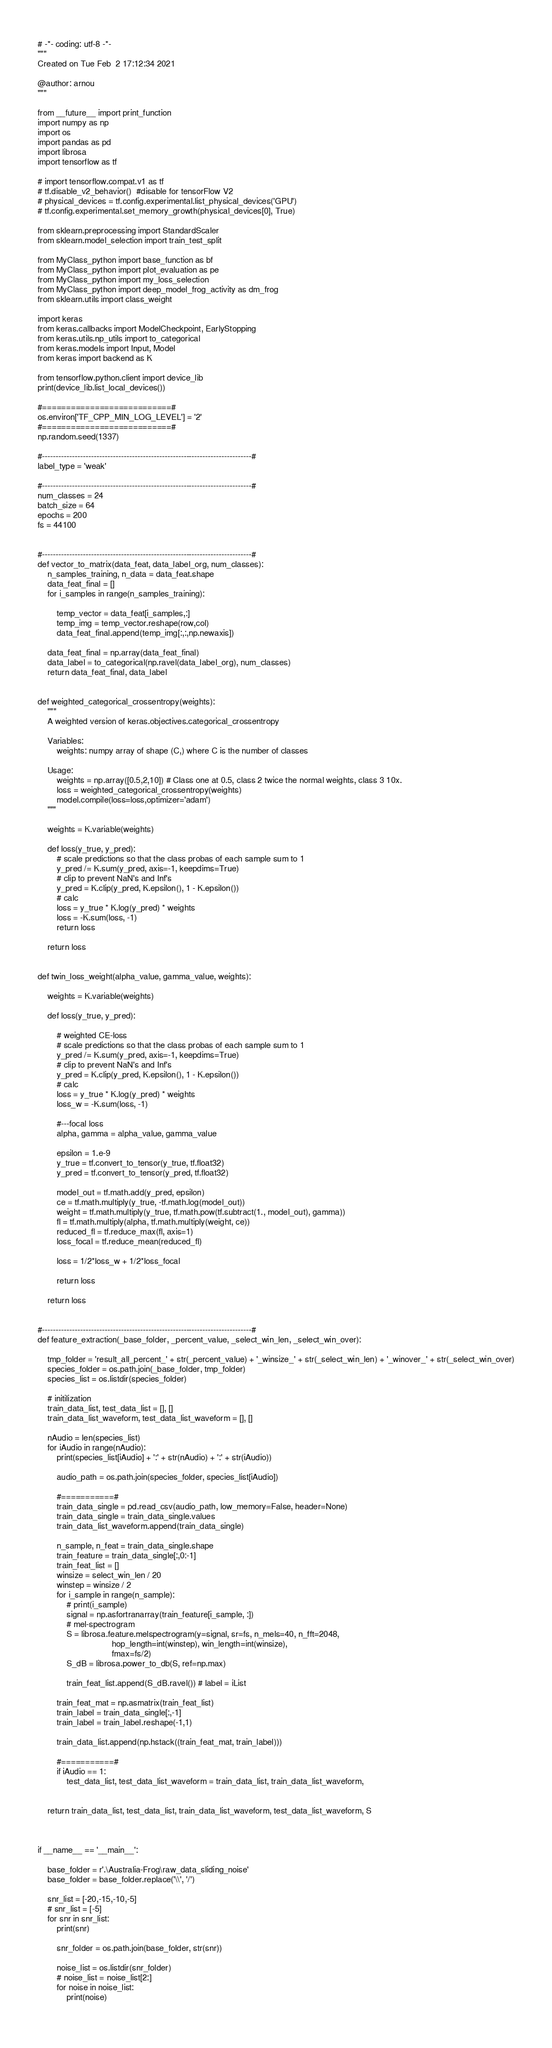Convert code to text. <code><loc_0><loc_0><loc_500><loc_500><_Python_># -*- coding: utf-8 -*-
"""
Created on Tue Feb  2 17:12:34 2021

@author: arnou
"""

from __future__ import print_function
import numpy as np
import os
import pandas as pd
import librosa
import tensorflow as tf

# import tensorflow.compat.v1 as tf
# tf.disable_v2_behavior()  #disable for tensorFlow V2
# physical_devices = tf.config.experimental.list_physical_devices('GPU')
# tf.config.experimental.set_memory_growth(physical_devices[0], True)

from sklearn.preprocessing import StandardScaler
from sklearn.model_selection import train_test_split

from MyClass_python import base_function as bf
from MyClass_python import plot_evaluation as pe
from MyClass_python import my_loss_selection
from MyClass_python import deep_model_frog_activity as dm_frog
from sklearn.utils import class_weight

import keras
from keras.callbacks import ModelCheckpoint, EarlyStopping
from keras.utils.np_utils import to_categorical
from keras.models import Input, Model
from keras import backend as K

from tensorflow.python.client import device_lib
print(device_lib.list_local_devices())

#===========================#
os.environ['TF_CPP_MIN_LOG_LEVEL'] = '2'
#===========================#
np.random.seed(1337)
    
#-----------------------------------------------------------------------------#
label_type = 'weak'

#-----------------------------------------------------------------------------#    
num_classes = 24
batch_size = 64
epochs = 200
fs = 44100


#-----------------------------------------------------------------------------#
def vector_to_matrix(data_feat, data_label_org, num_classes):
    n_samples_training, n_data = data_feat.shape 
    data_feat_final = []
    for i_samples in range(n_samples_training):
        
        temp_vector = data_feat[i_samples,:]    
        temp_img = temp_vector.reshape(row,col)    
        data_feat_final.append(temp_img[:,:,np.newaxis])

    data_feat_final = np.array(data_feat_final) 
    data_label = to_categorical(np.ravel(data_label_org), num_classes)    
    return data_feat_final, data_label


def weighted_categorical_crossentropy(weights):
    """
    A weighted version of keras.objectives.categorical_crossentropy

    Variables:
        weights: numpy array of shape (C,) where C is the number of classes

    Usage:
        weights = np.array([0.5,2,10]) # Class one at 0.5, class 2 twice the normal weights, class 3 10x.
        loss = weighted_categorical_crossentropy(weights)
        model.compile(loss=loss,optimizer='adam')
    """

    weights = K.variable(weights)

    def loss(y_true, y_pred):
        # scale predictions so that the class probas of each sample sum to 1
        y_pred /= K.sum(y_pred, axis=-1, keepdims=True)
        # clip to prevent NaN's and Inf's
        y_pred = K.clip(y_pred, K.epsilon(), 1 - K.epsilon())
        # calc
        loss = y_true * K.log(y_pred) * weights
        loss = -K.sum(loss, -1)
        return loss

    return loss


def twin_loss_weight(alpha_value, gamma_value, weights):
    
    weights = K.variable(weights)

    def loss(y_true, y_pred):
        
        # weighted CE-loss
        # scale predictions so that the class probas of each sample sum to 1
        y_pred /= K.sum(y_pred, axis=-1, keepdims=True)
        # clip to prevent NaN's and Inf's
        y_pred = K.clip(y_pred, K.epsilon(), 1 - K.epsilon())
        # calc
        loss = y_true * K.log(y_pred) * weights
        loss_w = -K.sum(loss, -1)
                
        #---focal loss
        alpha, gamma = alpha_value, gamma_value

        epsilon = 1.e-9
        y_true = tf.convert_to_tensor(y_true, tf.float32)
        y_pred = tf.convert_to_tensor(y_pred, tf.float32)
    
        model_out = tf.math.add(y_pred, epsilon)
        ce = tf.math.multiply(y_true, -tf.math.log(model_out))
        weight = tf.math.multiply(y_true, tf.math.pow(tf.subtract(1., model_out), gamma))
        fl = tf.math.multiply(alpha, tf.math.multiply(weight, ce))
        reduced_fl = tf.reduce_max(fl, axis=1)
        loss_focal = tf.reduce_mean(reduced_fl)
        
        loss = 1/2*loss_w + 1/2*loss_focal
                
        return loss

    return loss


#-----------------------------------------------------------------------------#
def feature_extraction(_base_folder, _percent_value, _select_win_len, _select_win_over):
    
    tmp_folder = 'result_all_percent_' + str(_percent_value) + '_winsize_' + str(_select_win_len) + '_winover_' + str(_select_win_over)
    species_folder = os.path.join(_base_folder, tmp_folder)    
    species_list = os.listdir(species_folder)
    
    # initilization
    train_data_list, test_data_list = [], []    
    train_data_list_waveform, test_data_list_waveform = [], []
    
    nAudio = len(species_list)
    for iAudio in range(nAudio):    
        print(species_list[iAudio] + ':' + str(nAudio) + ':' + str(iAudio))
        
        audio_path = os.path.join(species_folder, species_list[iAudio])
        
        #===========#                              
        train_data_single = pd.read_csv(audio_path, low_memory=False, header=None)                
        train_data_single = train_data_single.values
        train_data_list_waveform.append(train_data_single)
                       
        n_sample, n_feat = train_data_single.shape    
        train_feature = train_data_single[:,0:-1]
        train_feat_list = []                
        winsize = select_win_len / 20 
        winstep = winsize / 2                                     
        for i_sample in range(n_sample):
            # print(i_sample)
            signal = np.asfortranarray(train_feature[i_sample, :])
            # mel-spectrogram                         
            S = librosa.feature.melspectrogram(y=signal, sr=fs, n_mels=40, n_fft=2048, 
                               hop_length=int(winstep), win_length=int(winsize),
                               fmax=fs/2)                   
            S_dB = librosa.power_to_db(S, ref=np.max)
            
            train_feat_list.append(S_dB.ravel()) # label = iList
                
        train_feat_mat = np.asmatrix(train_feat_list)   
        train_label = train_data_single[:,-1]
        train_label = train_label.reshape(-1,1)
                 
        train_data_list.append(np.hstack((train_feat_mat, train_label)))
        
        #===========#
        if iAudio == 1:
            test_data_list, test_data_list_waveform = train_data_list, train_data_list_waveform, 
   
                    
    return train_data_list, test_data_list, train_data_list_waveform, test_data_list_waveform, S



if __name__ == '__main__':
    
    base_folder = r'.\Australia-Frog\raw_data_sliding_noise'                
    base_folder = base_folder.replace('\\', '/')

    snr_list = [-20,-15,-10,-5]
    # snr_list = [-5]
    for snr in snr_list:
        print(snr)
        
        snr_folder = os.path.join(base_folder, str(snr))
        
        noise_list = os.listdir(snr_folder) 
        # noise_list = noise_list[2:]       
        for noise in noise_list:
            print(noise)
            </code> 